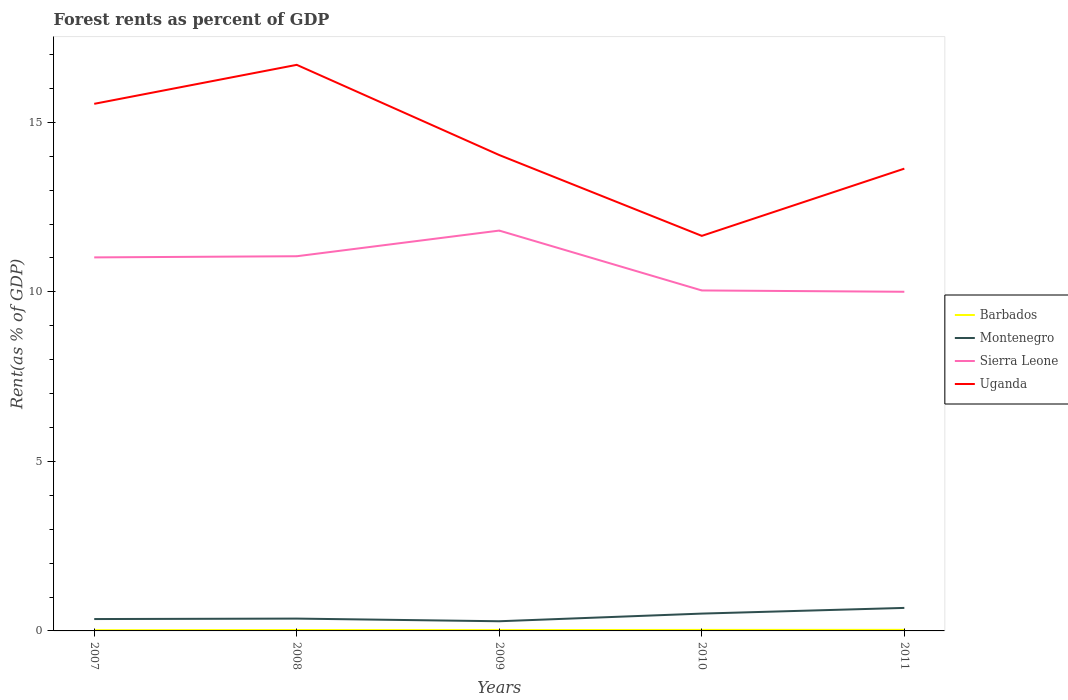Does the line corresponding to Sierra Leone intersect with the line corresponding to Montenegro?
Keep it short and to the point. No. Across all years, what is the maximum forest rent in Montenegro?
Ensure brevity in your answer.  0.29. What is the total forest rent in Montenegro in the graph?
Make the answer very short. -0.01. What is the difference between the highest and the second highest forest rent in Montenegro?
Give a very brief answer. 0.39. Is the forest rent in Sierra Leone strictly greater than the forest rent in Montenegro over the years?
Keep it short and to the point. No. What is the difference between two consecutive major ticks on the Y-axis?
Your response must be concise. 5. Are the values on the major ticks of Y-axis written in scientific E-notation?
Make the answer very short. No. Does the graph contain any zero values?
Your response must be concise. No. Does the graph contain grids?
Offer a very short reply. No. How are the legend labels stacked?
Your response must be concise. Vertical. What is the title of the graph?
Provide a succinct answer. Forest rents as percent of GDP. What is the label or title of the Y-axis?
Provide a short and direct response. Rent(as % of GDP). What is the Rent(as % of GDP) of Barbados in 2007?
Give a very brief answer. 0.02. What is the Rent(as % of GDP) in Montenegro in 2007?
Your response must be concise. 0.35. What is the Rent(as % of GDP) in Sierra Leone in 2007?
Provide a succinct answer. 11.02. What is the Rent(as % of GDP) in Uganda in 2007?
Give a very brief answer. 15.55. What is the Rent(as % of GDP) of Barbados in 2008?
Keep it short and to the point. 0.03. What is the Rent(as % of GDP) in Montenegro in 2008?
Offer a very short reply. 0.36. What is the Rent(as % of GDP) of Sierra Leone in 2008?
Give a very brief answer. 11.05. What is the Rent(as % of GDP) in Uganda in 2008?
Give a very brief answer. 16.7. What is the Rent(as % of GDP) in Barbados in 2009?
Ensure brevity in your answer.  0.02. What is the Rent(as % of GDP) of Montenegro in 2009?
Your answer should be compact. 0.29. What is the Rent(as % of GDP) of Sierra Leone in 2009?
Offer a terse response. 11.81. What is the Rent(as % of GDP) of Uganda in 2009?
Your response must be concise. 14.04. What is the Rent(as % of GDP) in Barbados in 2010?
Provide a short and direct response. 0.03. What is the Rent(as % of GDP) in Montenegro in 2010?
Keep it short and to the point. 0.51. What is the Rent(as % of GDP) of Sierra Leone in 2010?
Keep it short and to the point. 10.04. What is the Rent(as % of GDP) in Uganda in 2010?
Offer a very short reply. 11.65. What is the Rent(as % of GDP) in Barbados in 2011?
Your response must be concise. 0.03. What is the Rent(as % of GDP) in Montenegro in 2011?
Keep it short and to the point. 0.68. What is the Rent(as % of GDP) in Sierra Leone in 2011?
Provide a short and direct response. 10. What is the Rent(as % of GDP) in Uganda in 2011?
Provide a succinct answer. 13.64. Across all years, what is the maximum Rent(as % of GDP) of Barbados?
Provide a short and direct response. 0.03. Across all years, what is the maximum Rent(as % of GDP) of Montenegro?
Your answer should be compact. 0.68. Across all years, what is the maximum Rent(as % of GDP) in Sierra Leone?
Ensure brevity in your answer.  11.81. Across all years, what is the maximum Rent(as % of GDP) in Uganda?
Keep it short and to the point. 16.7. Across all years, what is the minimum Rent(as % of GDP) in Barbados?
Provide a succinct answer. 0.02. Across all years, what is the minimum Rent(as % of GDP) in Montenegro?
Your response must be concise. 0.29. Across all years, what is the minimum Rent(as % of GDP) in Sierra Leone?
Give a very brief answer. 10. Across all years, what is the minimum Rent(as % of GDP) in Uganda?
Keep it short and to the point. 11.65. What is the total Rent(as % of GDP) in Barbados in the graph?
Ensure brevity in your answer.  0.13. What is the total Rent(as % of GDP) in Montenegro in the graph?
Your response must be concise. 2.19. What is the total Rent(as % of GDP) of Sierra Leone in the graph?
Offer a very short reply. 53.92. What is the total Rent(as % of GDP) of Uganda in the graph?
Your response must be concise. 71.57. What is the difference between the Rent(as % of GDP) of Barbados in 2007 and that in 2008?
Give a very brief answer. -0.01. What is the difference between the Rent(as % of GDP) in Montenegro in 2007 and that in 2008?
Your answer should be compact. -0.01. What is the difference between the Rent(as % of GDP) in Sierra Leone in 2007 and that in 2008?
Give a very brief answer. -0.03. What is the difference between the Rent(as % of GDP) of Uganda in 2007 and that in 2008?
Your response must be concise. -1.15. What is the difference between the Rent(as % of GDP) in Barbados in 2007 and that in 2009?
Offer a terse response. -0. What is the difference between the Rent(as % of GDP) in Montenegro in 2007 and that in 2009?
Provide a succinct answer. 0.06. What is the difference between the Rent(as % of GDP) in Sierra Leone in 2007 and that in 2009?
Provide a succinct answer. -0.79. What is the difference between the Rent(as % of GDP) in Uganda in 2007 and that in 2009?
Your response must be concise. 1.51. What is the difference between the Rent(as % of GDP) in Barbados in 2007 and that in 2010?
Offer a very short reply. -0.01. What is the difference between the Rent(as % of GDP) of Montenegro in 2007 and that in 2010?
Give a very brief answer. -0.16. What is the difference between the Rent(as % of GDP) in Sierra Leone in 2007 and that in 2010?
Provide a succinct answer. 0.98. What is the difference between the Rent(as % of GDP) in Uganda in 2007 and that in 2010?
Provide a short and direct response. 3.89. What is the difference between the Rent(as % of GDP) of Barbados in 2007 and that in 2011?
Ensure brevity in your answer.  -0.01. What is the difference between the Rent(as % of GDP) of Montenegro in 2007 and that in 2011?
Keep it short and to the point. -0.33. What is the difference between the Rent(as % of GDP) in Sierra Leone in 2007 and that in 2011?
Provide a short and direct response. 1.01. What is the difference between the Rent(as % of GDP) of Uganda in 2007 and that in 2011?
Your answer should be compact. 1.91. What is the difference between the Rent(as % of GDP) of Barbados in 2008 and that in 2009?
Your answer should be very brief. 0. What is the difference between the Rent(as % of GDP) of Montenegro in 2008 and that in 2009?
Provide a short and direct response. 0.08. What is the difference between the Rent(as % of GDP) of Sierra Leone in 2008 and that in 2009?
Your answer should be very brief. -0.76. What is the difference between the Rent(as % of GDP) of Uganda in 2008 and that in 2009?
Your answer should be very brief. 2.66. What is the difference between the Rent(as % of GDP) in Barbados in 2008 and that in 2010?
Your response must be concise. -0. What is the difference between the Rent(as % of GDP) of Montenegro in 2008 and that in 2010?
Provide a short and direct response. -0.15. What is the difference between the Rent(as % of GDP) of Sierra Leone in 2008 and that in 2010?
Provide a succinct answer. 1.01. What is the difference between the Rent(as % of GDP) in Uganda in 2008 and that in 2010?
Provide a succinct answer. 5.04. What is the difference between the Rent(as % of GDP) in Barbados in 2008 and that in 2011?
Make the answer very short. -0.01. What is the difference between the Rent(as % of GDP) of Montenegro in 2008 and that in 2011?
Offer a very short reply. -0.32. What is the difference between the Rent(as % of GDP) in Sierra Leone in 2008 and that in 2011?
Your answer should be compact. 1.05. What is the difference between the Rent(as % of GDP) in Uganda in 2008 and that in 2011?
Your answer should be very brief. 3.06. What is the difference between the Rent(as % of GDP) of Barbados in 2009 and that in 2010?
Provide a short and direct response. -0. What is the difference between the Rent(as % of GDP) of Montenegro in 2009 and that in 2010?
Ensure brevity in your answer.  -0.23. What is the difference between the Rent(as % of GDP) of Sierra Leone in 2009 and that in 2010?
Ensure brevity in your answer.  1.77. What is the difference between the Rent(as % of GDP) of Uganda in 2009 and that in 2010?
Offer a terse response. 2.38. What is the difference between the Rent(as % of GDP) in Barbados in 2009 and that in 2011?
Give a very brief answer. -0.01. What is the difference between the Rent(as % of GDP) in Montenegro in 2009 and that in 2011?
Offer a terse response. -0.39. What is the difference between the Rent(as % of GDP) of Sierra Leone in 2009 and that in 2011?
Offer a terse response. 1.8. What is the difference between the Rent(as % of GDP) of Uganda in 2009 and that in 2011?
Ensure brevity in your answer.  0.4. What is the difference between the Rent(as % of GDP) in Barbados in 2010 and that in 2011?
Offer a very short reply. -0. What is the difference between the Rent(as % of GDP) of Montenegro in 2010 and that in 2011?
Offer a terse response. -0.17. What is the difference between the Rent(as % of GDP) in Sierra Leone in 2010 and that in 2011?
Keep it short and to the point. 0.04. What is the difference between the Rent(as % of GDP) in Uganda in 2010 and that in 2011?
Give a very brief answer. -1.98. What is the difference between the Rent(as % of GDP) in Barbados in 2007 and the Rent(as % of GDP) in Montenegro in 2008?
Provide a short and direct response. -0.34. What is the difference between the Rent(as % of GDP) in Barbados in 2007 and the Rent(as % of GDP) in Sierra Leone in 2008?
Make the answer very short. -11.03. What is the difference between the Rent(as % of GDP) of Barbados in 2007 and the Rent(as % of GDP) of Uganda in 2008?
Provide a succinct answer. -16.68. What is the difference between the Rent(as % of GDP) in Montenegro in 2007 and the Rent(as % of GDP) in Sierra Leone in 2008?
Keep it short and to the point. -10.7. What is the difference between the Rent(as % of GDP) of Montenegro in 2007 and the Rent(as % of GDP) of Uganda in 2008?
Make the answer very short. -16.35. What is the difference between the Rent(as % of GDP) in Sierra Leone in 2007 and the Rent(as % of GDP) in Uganda in 2008?
Provide a succinct answer. -5.68. What is the difference between the Rent(as % of GDP) in Barbados in 2007 and the Rent(as % of GDP) in Montenegro in 2009?
Offer a very short reply. -0.26. What is the difference between the Rent(as % of GDP) in Barbados in 2007 and the Rent(as % of GDP) in Sierra Leone in 2009?
Ensure brevity in your answer.  -11.79. What is the difference between the Rent(as % of GDP) of Barbados in 2007 and the Rent(as % of GDP) of Uganda in 2009?
Provide a short and direct response. -14.02. What is the difference between the Rent(as % of GDP) in Montenegro in 2007 and the Rent(as % of GDP) in Sierra Leone in 2009?
Give a very brief answer. -11.46. What is the difference between the Rent(as % of GDP) of Montenegro in 2007 and the Rent(as % of GDP) of Uganda in 2009?
Provide a succinct answer. -13.69. What is the difference between the Rent(as % of GDP) of Sierra Leone in 2007 and the Rent(as % of GDP) of Uganda in 2009?
Provide a short and direct response. -3.02. What is the difference between the Rent(as % of GDP) in Barbados in 2007 and the Rent(as % of GDP) in Montenegro in 2010?
Provide a short and direct response. -0.49. What is the difference between the Rent(as % of GDP) in Barbados in 2007 and the Rent(as % of GDP) in Sierra Leone in 2010?
Offer a very short reply. -10.02. What is the difference between the Rent(as % of GDP) in Barbados in 2007 and the Rent(as % of GDP) in Uganda in 2010?
Your answer should be compact. -11.63. What is the difference between the Rent(as % of GDP) in Montenegro in 2007 and the Rent(as % of GDP) in Sierra Leone in 2010?
Your response must be concise. -9.69. What is the difference between the Rent(as % of GDP) of Montenegro in 2007 and the Rent(as % of GDP) of Uganda in 2010?
Your answer should be compact. -11.3. What is the difference between the Rent(as % of GDP) of Sierra Leone in 2007 and the Rent(as % of GDP) of Uganda in 2010?
Offer a very short reply. -0.63. What is the difference between the Rent(as % of GDP) of Barbados in 2007 and the Rent(as % of GDP) of Montenegro in 2011?
Your answer should be compact. -0.66. What is the difference between the Rent(as % of GDP) of Barbados in 2007 and the Rent(as % of GDP) of Sierra Leone in 2011?
Offer a terse response. -9.98. What is the difference between the Rent(as % of GDP) of Barbados in 2007 and the Rent(as % of GDP) of Uganda in 2011?
Your response must be concise. -13.61. What is the difference between the Rent(as % of GDP) in Montenegro in 2007 and the Rent(as % of GDP) in Sierra Leone in 2011?
Your answer should be compact. -9.65. What is the difference between the Rent(as % of GDP) in Montenegro in 2007 and the Rent(as % of GDP) in Uganda in 2011?
Make the answer very short. -13.29. What is the difference between the Rent(as % of GDP) in Sierra Leone in 2007 and the Rent(as % of GDP) in Uganda in 2011?
Ensure brevity in your answer.  -2.62. What is the difference between the Rent(as % of GDP) of Barbados in 2008 and the Rent(as % of GDP) of Montenegro in 2009?
Your response must be concise. -0.26. What is the difference between the Rent(as % of GDP) in Barbados in 2008 and the Rent(as % of GDP) in Sierra Leone in 2009?
Offer a very short reply. -11.78. What is the difference between the Rent(as % of GDP) of Barbados in 2008 and the Rent(as % of GDP) of Uganda in 2009?
Ensure brevity in your answer.  -14.01. What is the difference between the Rent(as % of GDP) in Montenegro in 2008 and the Rent(as % of GDP) in Sierra Leone in 2009?
Keep it short and to the point. -11.44. What is the difference between the Rent(as % of GDP) of Montenegro in 2008 and the Rent(as % of GDP) of Uganda in 2009?
Your response must be concise. -13.67. What is the difference between the Rent(as % of GDP) of Sierra Leone in 2008 and the Rent(as % of GDP) of Uganda in 2009?
Your response must be concise. -2.98. What is the difference between the Rent(as % of GDP) of Barbados in 2008 and the Rent(as % of GDP) of Montenegro in 2010?
Your answer should be compact. -0.48. What is the difference between the Rent(as % of GDP) of Barbados in 2008 and the Rent(as % of GDP) of Sierra Leone in 2010?
Provide a succinct answer. -10.02. What is the difference between the Rent(as % of GDP) of Barbados in 2008 and the Rent(as % of GDP) of Uganda in 2010?
Provide a succinct answer. -11.63. What is the difference between the Rent(as % of GDP) of Montenegro in 2008 and the Rent(as % of GDP) of Sierra Leone in 2010?
Offer a very short reply. -9.68. What is the difference between the Rent(as % of GDP) of Montenegro in 2008 and the Rent(as % of GDP) of Uganda in 2010?
Offer a very short reply. -11.29. What is the difference between the Rent(as % of GDP) of Sierra Leone in 2008 and the Rent(as % of GDP) of Uganda in 2010?
Offer a very short reply. -0.6. What is the difference between the Rent(as % of GDP) of Barbados in 2008 and the Rent(as % of GDP) of Montenegro in 2011?
Offer a very short reply. -0.65. What is the difference between the Rent(as % of GDP) in Barbados in 2008 and the Rent(as % of GDP) in Sierra Leone in 2011?
Your answer should be very brief. -9.98. What is the difference between the Rent(as % of GDP) of Barbados in 2008 and the Rent(as % of GDP) of Uganda in 2011?
Provide a short and direct response. -13.61. What is the difference between the Rent(as % of GDP) of Montenegro in 2008 and the Rent(as % of GDP) of Sierra Leone in 2011?
Ensure brevity in your answer.  -9.64. What is the difference between the Rent(as % of GDP) of Montenegro in 2008 and the Rent(as % of GDP) of Uganda in 2011?
Your answer should be very brief. -13.27. What is the difference between the Rent(as % of GDP) of Sierra Leone in 2008 and the Rent(as % of GDP) of Uganda in 2011?
Your answer should be very brief. -2.58. What is the difference between the Rent(as % of GDP) in Barbados in 2009 and the Rent(as % of GDP) in Montenegro in 2010?
Offer a very short reply. -0.49. What is the difference between the Rent(as % of GDP) in Barbados in 2009 and the Rent(as % of GDP) in Sierra Leone in 2010?
Ensure brevity in your answer.  -10.02. What is the difference between the Rent(as % of GDP) of Barbados in 2009 and the Rent(as % of GDP) of Uganda in 2010?
Keep it short and to the point. -11.63. What is the difference between the Rent(as % of GDP) in Montenegro in 2009 and the Rent(as % of GDP) in Sierra Leone in 2010?
Ensure brevity in your answer.  -9.76. What is the difference between the Rent(as % of GDP) of Montenegro in 2009 and the Rent(as % of GDP) of Uganda in 2010?
Give a very brief answer. -11.37. What is the difference between the Rent(as % of GDP) in Sierra Leone in 2009 and the Rent(as % of GDP) in Uganda in 2010?
Keep it short and to the point. 0.16. What is the difference between the Rent(as % of GDP) of Barbados in 2009 and the Rent(as % of GDP) of Montenegro in 2011?
Provide a succinct answer. -0.65. What is the difference between the Rent(as % of GDP) in Barbados in 2009 and the Rent(as % of GDP) in Sierra Leone in 2011?
Your answer should be compact. -9.98. What is the difference between the Rent(as % of GDP) in Barbados in 2009 and the Rent(as % of GDP) in Uganda in 2011?
Offer a terse response. -13.61. What is the difference between the Rent(as % of GDP) in Montenegro in 2009 and the Rent(as % of GDP) in Sierra Leone in 2011?
Give a very brief answer. -9.72. What is the difference between the Rent(as % of GDP) in Montenegro in 2009 and the Rent(as % of GDP) in Uganda in 2011?
Offer a very short reply. -13.35. What is the difference between the Rent(as % of GDP) of Sierra Leone in 2009 and the Rent(as % of GDP) of Uganda in 2011?
Provide a succinct answer. -1.83. What is the difference between the Rent(as % of GDP) of Barbados in 2010 and the Rent(as % of GDP) of Montenegro in 2011?
Give a very brief answer. -0.65. What is the difference between the Rent(as % of GDP) in Barbados in 2010 and the Rent(as % of GDP) in Sierra Leone in 2011?
Provide a short and direct response. -9.97. What is the difference between the Rent(as % of GDP) of Barbados in 2010 and the Rent(as % of GDP) of Uganda in 2011?
Your response must be concise. -13.61. What is the difference between the Rent(as % of GDP) in Montenegro in 2010 and the Rent(as % of GDP) in Sierra Leone in 2011?
Provide a succinct answer. -9.49. What is the difference between the Rent(as % of GDP) in Montenegro in 2010 and the Rent(as % of GDP) in Uganda in 2011?
Your answer should be very brief. -13.12. What is the difference between the Rent(as % of GDP) in Sierra Leone in 2010 and the Rent(as % of GDP) in Uganda in 2011?
Keep it short and to the point. -3.59. What is the average Rent(as % of GDP) in Barbados per year?
Your response must be concise. 0.03. What is the average Rent(as % of GDP) of Montenegro per year?
Your answer should be compact. 0.44. What is the average Rent(as % of GDP) in Sierra Leone per year?
Your response must be concise. 10.78. What is the average Rent(as % of GDP) in Uganda per year?
Your answer should be compact. 14.31. In the year 2007, what is the difference between the Rent(as % of GDP) in Barbados and Rent(as % of GDP) in Montenegro?
Your response must be concise. -0.33. In the year 2007, what is the difference between the Rent(as % of GDP) in Barbados and Rent(as % of GDP) in Sierra Leone?
Offer a terse response. -11. In the year 2007, what is the difference between the Rent(as % of GDP) of Barbados and Rent(as % of GDP) of Uganda?
Keep it short and to the point. -15.53. In the year 2007, what is the difference between the Rent(as % of GDP) in Montenegro and Rent(as % of GDP) in Sierra Leone?
Provide a short and direct response. -10.67. In the year 2007, what is the difference between the Rent(as % of GDP) in Montenegro and Rent(as % of GDP) in Uganda?
Make the answer very short. -15.2. In the year 2007, what is the difference between the Rent(as % of GDP) in Sierra Leone and Rent(as % of GDP) in Uganda?
Offer a terse response. -4.53. In the year 2008, what is the difference between the Rent(as % of GDP) of Barbados and Rent(as % of GDP) of Montenegro?
Your answer should be compact. -0.34. In the year 2008, what is the difference between the Rent(as % of GDP) in Barbados and Rent(as % of GDP) in Sierra Leone?
Your answer should be compact. -11.03. In the year 2008, what is the difference between the Rent(as % of GDP) in Barbados and Rent(as % of GDP) in Uganda?
Offer a very short reply. -16.67. In the year 2008, what is the difference between the Rent(as % of GDP) of Montenegro and Rent(as % of GDP) of Sierra Leone?
Keep it short and to the point. -10.69. In the year 2008, what is the difference between the Rent(as % of GDP) of Montenegro and Rent(as % of GDP) of Uganda?
Your answer should be compact. -16.33. In the year 2008, what is the difference between the Rent(as % of GDP) in Sierra Leone and Rent(as % of GDP) in Uganda?
Your answer should be compact. -5.65. In the year 2009, what is the difference between the Rent(as % of GDP) of Barbados and Rent(as % of GDP) of Montenegro?
Make the answer very short. -0.26. In the year 2009, what is the difference between the Rent(as % of GDP) of Barbados and Rent(as % of GDP) of Sierra Leone?
Provide a short and direct response. -11.78. In the year 2009, what is the difference between the Rent(as % of GDP) in Barbados and Rent(as % of GDP) in Uganda?
Offer a very short reply. -14.01. In the year 2009, what is the difference between the Rent(as % of GDP) in Montenegro and Rent(as % of GDP) in Sierra Leone?
Offer a very short reply. -11.52. In the year 2009, what is the difference between the Rent(as % of GDP) in Montenegro and Rent(as % of GDP) in Uganda?
Make the answer very short. -13.75. In the year 2009, what is the difference between the Rent(as % of GDP) in Sierra Leone and Rent(as % of GDP) in Uganda?
Your answer should be compact. -2.23. In the year 2010, what is the difference between the Rent(as % of GDP) in Barbados and Rent(as % of GDP) in Montenegro?
Keep it short and to the point. -0.48. In the year 2010, what is the difference between the Rent(as % of GDP) of Barbados and Rent(as % of GDP) of Sierra Leone?
Your answer should be compact. -10.01. In the year 2010, what is the difference between the Rent(as % of GDP) in Barbados and Rent(as % of GDP) in Uganda?
Your answer should be very brief. -11.62. In the year 2010, what is the difference between the Rent(as % of GDP) of Montenegro and Rent(as % of GDP) of Sierra Leone?
Ensure brevity in your answer.  -9.53. In the year 2010, what is the difference between the Rent(as % of GDP) of Montenegro and Rent(as % of GDP) of Uganda?
Offer a very short reply. -11.14. In the year 2010, what is the difference between the Rent(as % of GDP) in Sierra Leone and Rent(as % of GDP) in Uganda?
Your answer should be compact. -1.61. In the year 2011, what is the difference between the Rent(as % of GDP) in Barbados and Rent(as % of GDP) in Montenegro?
Your answer should be compact. -0.65. In the year 2011, what is the difference between the Rent(as % of GDP) in Barbados and Rent(as % of GDP) in Sierra Leone?
Your response must be concise. -9.97. In the year 2011, what is the difference between the Rent(as % of GDP) in Barbados and Rent(as % of GDP) in Uganda?
Your response must be concise. -13.6. In the year 2011, what is the difference between the Rent(as % of GDP) in Montenegro and Rent(as % of GDP) in Sierra Leone?
Provide a succinct answer. -9.32. In the year 2011, what is the difference between the Rent(as % of GDP) of Montenegro and Rent(as % of GDP) of Uganda?
Make the answer very short. -12.96. In the year 2011, what is the difference between the Rent(as % of GDP) in Sierra Leone and Rent(as % of GDP) in Uganda?
Offer a very short reply. -3.63. What is the ratio of the Rent(as % of GDP) of Barbados in 2007 to that in 2008?
Offer a very short reply. 0.8. What is the ratio of the Rent(as % of GDP) of Montenegro in 2007 to that in 2008?
Provide a short and direct response. 0.96. What is the ratio of the Rent(as % of GDP) in Uganda in 2007 to that in 2008?
Your answer should be very brief. 0.93. What is the ratio of the Rent(as % of GDP) in Barbados in 2007 to that in 2009?
Provide a succinct answer. 0.85. What is the ratio of the Rent(as % of GDP) of Montenegro in 2007 to that in 2009?
Ensure brevity in your answer.  1.23. What is the ratio of the Rent(as % of GDP) of Sierra Leone in 2007 to that in 2009?
Keep it short and to the point. 0.93. What is the ratio of the Rent(as % of GDP) in Uganda in 2007 to that in 2009?
Offer a very short reply. 1.11. What is the ratio of the Rent(as % of GDP) of Barbados in 2007 to that in 2010?
Your answer should be compact. 0.71. What is the ratio of the Rent(as % of GDP) in Montenegro in 2007 to that in 2010?
Ensure brevity in your answer.  0.69. What is the ratio of the Rent(as % of GDP) in Sierra Leone in 2007 to that in 2010?
Your response must be concise. 1.1. What is the ratio of the Rent(as % of GDP) in Uganda in 2007 to that in 2010?
Provide a succinct answer. 1.33. What is the ratio of the Rent(as % of GDP) of Barbados in 2007 to that in 2011?
Ensure brevity in your answer.  0.66. What is the ratio of the Rent(as % of GDP) in Montenegro in 2007 to that in 2011?
Ensure brevity in your answer.  0.52. What is the ratio of the Rent(as % of GDP) in Sierra Leone in 2007 to that in 2011?
Keep it short and to the point. 1.1. What is the ratio of the Rent(as % of GDP) of Uganda in 2007 to that in 2011?
Your response must be concise. 1.14. What is the ratio of the Rent(as % of GDP) of Barbados in 2008 to that in 2009?
Provide a short and direct response. 1.06. What is the ratio of the Rent(as % of GDP) of Montenegro in 2008 to that in 2009?
Your response must be concise. 1.27. What is the ratio of the Rent(as % of GDP) in Sierra Leone in 2008 to that in 2009?
Offer a terse response. 0.94. What is the ratio of the Rent(as % of GDP) in Uganda in 2008 to that in 2009?
Your answer should be compact. 1.19. What is the ratio of the Rent(as % of GDP) in Barbados in 2008 to that in 2010?
Your response must be concise. 0.89. What is the ratio of the Rent(as % of GDP) of Montenegro in 2008 to that in 2010?
Your answer should be compact. 0.71. What is the ratio of the Rent(as % of GDP) of Sierra Leone in 2008 to that in 2010?
Ensure brevity in your answer.  1.1. What is the ratio of the Rent(as % of GDP) of Uganda in 2008 to that in 2010?
Provide a succinct answer. 1.43. What is the ratio of the Rent(as % of GDP) of Barbados in 2008 to that in 2011?
Offer a terse response. 0.83. What is the ratio of the Rent(as % of GDP) of Montenegro in 2008 to that in 2011?
Your answer should be very brief. 0.54. What is the ratio of the Rent(as % of GDP) of Sierra Leone in 2008 to that in 2011?
Keep it short and to the point. 1.1. What is the ratio of the Rent(as % of GDP) in Uganda in 2008 to that in 2011?
Provide a succinct answer. 1.22. What is the ratio of the Rent(as % of GDP) of Barbados in 2009 to that in 2010?
Make the answer very short. 0.84. What is the ratio of the Rent(as % of GDP) of Montenegro in 2009 to that in 2010?
Give a very brief answer. 0.56. What is the ratio of the Rent(as % of GDP) in Sierra Leone in 2009 to that in 2010?
Provide a short and direct response. 1.18. What is the ratio of the Rent(as % of GDP) of Uganda in 2009 to that in 2010?
Your response must be concise. 1.2. What is the ratio of the Rent(as % of GDP) in Barbados in 2009 to that in 2011?
Keep it short and to the point. 0.78. What is the ratio of the Rent(as % of GDP) in Montenegro in 2009 to that in 2011?
Your response must be concise. 0.42. What is the ratio of the Rent(as % of GDP) of Sierra Leone in 2009 to that in 2011?
Provide a succinct answer. 1.18. What is the ratio of the Rent(as % of GDP) of Uganda in 2009 to that in 2011?
Your answer should be very brief. 1.03. What is the ratio of the Rent(as % of GDP) of Barbados in 2010 to that in 2011?
Provide a short and direct response. 0.93. What is the ratio of the Rent(as % of GDP) of Montenegro in 2010 to that in 2011?
Make the answer very short. 0.75. What is the ratio of the Rent(as % of GDP) in Uganda in 2010 to that in 2011?
Make the answer very short. 0.85. What is the difference between the highest and the second highest Rent(as % of GDP) in Barbados?
Your answer should be compact. 0. What is the difference between the highest and the second highest Rent(as % of GDP) of Montenegro?
Ensure brevity in your answer.  0.17. What is the difference between the highest and the second highest Rent(as % of GDP) of Sierra Leone?
Your answer should be compact. 0.76. What is the difference between the highest and the second highest Rent(as % of GDP) of Uganda?
Provide a short and direct response. 1.15. What is the difference between the highest and the lowest Rent(as % of GDP) in Barbados?
Give a very brief answer. 0.01. What is the difference between the highest and the lowest Rent(as % of GDP) of Montenegro?
Your answer should be very brief. 0.39. What is the difference between the highest and the lowest Rent(as % of GDP) of Sierra Leone?
Give a very brief answer. 1.8. What is the difference between the highest and the lowest Rent(as % of GDP) of Uganda?
Your answer should be very brief. 5.04. 